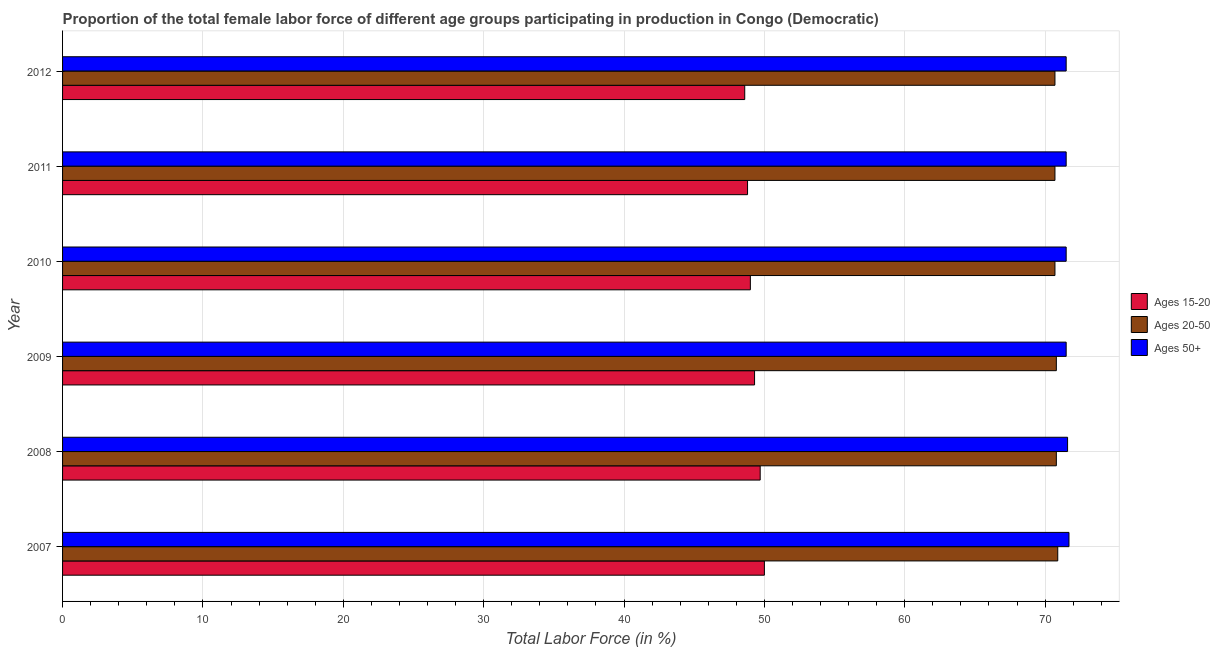Are the number of bars per tick equal to the number of legend labels?
Offer a terse response. Yes. Are the number of bars on each tick of the Y-axis equal?
Ensure brevity in your answer.  Yes. What is the label of the 6th group of bars from the top?
Provide a succinct answer. 2007. In how many cases, is the number of bars for a given year not equal to the number of legend labels?
Your response must be concise. 0. What is the percentage of female labor force above age 50 in 2007?
Offer a very short reply. 71.7. Across all years, what is the maximum percentage of female labor force within the age group 15-20?
Give a very brief answer. 50. Across all years, what is the minimum percentage of female labor force above age 50?
Your answer should be very brief. 71.5. What is the total percentage of female labor force above age 50 in the graph?
Provide a short and direct response. 429.3. What is the difference between the percentage of female labor force within the age group 20-50 in 2010 and that in 2011?
Give a very brief answer. 0. What is the difference between the percentage of female labor force within the age group 20-50 in 2010 and the percentage of female labor force above age 50 in 2009?
Your answer should be very brief. -0.8. What is the average percentage of female labor force above age 50 per year?
Keep it short and to the point. 71.55. In the year 2011, what is the difference between the percentage of female labor force within the age group 15-20 and percentage of female labor force within the age group 20-50?
Keep it short and to the point. -21.9. In how many years, is the percentage of female labor force above age 50 greater than 56 %?
Your answer should be very brief. 6. What is the ratio of the percentage of female labor force within the age group 15-20 in 2010 to that in 2012?
Ensure brevity in your answer.  1.01. Is the percentage of female labor force above age 50 in 2007 less than that in 2012?
Your response must be concise. No. Is the difference between the percentage of female labor force within the age group 15-20 in 2010 and 2011 greater than the difference between the percentage of female labor force within the age group 20-50 in 2010 and 2011?
Give a very brief answer. Yes. What is the difference between the highest and the second highest percentage of female labor force within the age group 20-50?
Offer a terse response. 0.1. Is the sum of the percentage of female labor force above age 50 in 2008 and 2010 greater than the maximum percentage of female labor force within the age group 20-50 across all years?
Keep it short and to the point. Yes. What does the 2nd bar from the top in 2009 represents?
Keep it short and to the point. Ages 20-50. What does the 3rd bar from the bottom in 2007 represents?
Offer a very short reply. Ages 50+. Is it the case that in every year, the sum of the percentage of female labor force within the age group 15-20 and percentage of female labor force within the age group 20-50 is greater than the percentage of female labor force above age 50?
Your response must be concise. Yes. How many bars are there?
Provide a short and direct response. 18. Are all the bars in the graph horizontal?
Offer a very short reply. Yes. Does the graph contain any zero values?
Keep it short and to the point. No. Does the graph contain grids?
Make the answer very short. Yes. Where does the legend appear in the graph?
Offer a terse response. Center right. How many legend labels are there?
Give a very brief answer. 3. How are the legend labels stacked?
Make the answer very short. Vertical. What is the title of the graph?
Make the answer very short. Proportion of the total female labor force of different age groups participating in production in Congo (Democratic). What is the Total Labor Force (in %) in Ages 15-20 in 2007?
Your response must be concise. 50. What is the Total Labor Force (in %) in Ages 20-50 in 2007?
Offer a very short reply. 70.9. What is the Total Labor Force (in %) in Ages 50+ in 2007?
Keep it short and to the point. 71.7. What is the Total Labor Force (in %) of Ages 15-20 in 2008?
Your answer should be compact. 49.7. What is the Total Labor Force (in %) in Ages 20-50 in 2008?
Keep it short and to the point. 70.8. What is the Total Labor Force (in %) in Ages 50+ in 2008?
Your answer should be very brief. 71.6. What is the Total Labor Force (in %) of Ages 15-20 in 2009?
Provide a short and direct response. 49.3. What is the Total Labor Force (in %) of Ages 20-50 in 2009?
Provide a succinct answer. 70.8. What is the Total Labor Force (in %) in Ages 50+ in 2009?
Your response must be concise. 71.5. What is the Total Labor Force (in %) in Ages 15-20 in 2010?
Offer a terse response. 49. What is the Total Labor Force (in %) in Ages 20-50 in 2010?
Offer a very short reply. 70.7. What is the Total Labor Force (in %) of Ages 50+ in 2010?
Provide a succinct answer. 71.5. What is the Total Labor Force (in %) of Ages 15-20 in 2011?
Your response must be concise. 48.8. What is the Total Labor Force (in %) of Ages 20-50 in 2011?
Offer a terse response. 70.7. What is the Total Labor Force (in %) in Ages 50+ in 2011?
Ensure brevity in your answer.  71.5. What is the Total Labor Force (in %) in Ages 15-20 in 2012?
Ensure brevity in your answer.  48.6. What is the Total Labor Force (in %) of Ages 20-50 in 2012?
Make the answer very short. 70.7. What is the Total Labor Force (in %) of Ages 50+ in 2012?
Offer a very short reply. 71.5. Across all years, what is the maximum Total Labor Force (in %) of Ages 15-20?
Keep it short and to the point. 50. Across all years, what is the maximum Total Labor Force (in %) in Ages 20-50?
Offer a terse response. 70.9. Across all years, what is the maximum Total Labor Force (in %) in Ages 50+?
Make the answer very short. 71.7. Across all years, what is the minimum Total Labor Force (in %) in Ages 15-20?
Offer a very short reply. 48.6. Across all years, what is the minimum Total Labor Force (in %) in Ages 20-50?
Your response must be concise. 70.7. Across all years, what is the minimum Total Labor Force (in %) of Ages 50+?
Your answer should be compact. 71.5. What is the total Total Labor Force (in %) of Ages 15-20 in the graph?
Make the answer very short. 295.4. What is the total Total Labor Force (in %) in Ages 20-50 in the graph?
Provide a short and direct response. 424.6. What is the total Total Labor Force (in %) of Ages 50+ in the graph?
Your response must be concise. 429.3. What is the difference between the Total Labor Force (in %) in Ages 15-20 in 2007 and that in 2008?
Provide a succinct answer. 0.3. What is the difference between the Total Labor Force (in %) of Ages 50+ in 2007 and that in 2009?
Make the answer very short. 0.2. What is the difference between the Total Labor Force (in %) in Ages 15-20 in 2007 and that in 2010?
Provide a succinct answer. 1. What is the difference between the Total Labor Force (in %) of Ages 20-50 in 2007 and that in 2010?
Keep it short and to the point. 0.2. What is the difference between the Total Labor Force (in %) in Ages 50+ in 2007 and that in 2010?
Your answer should be very brief. 0.2. What is the difference between the Total Labor Force (in %) of Ages 15-20 in 2007 and that in 2011?
Your answer should be compact. 1.2. What is the difference between the Total Labor Force (in %) in Ages 20-50 in 2007 and that in 2011?
Make the answer very short. 0.2. What is the difference between the Total Labor Force (in %) in Ages 50+ in 2007 and that in 2011?
Keep it short and to the point. 0.2. What is the difference between the Total Labor Force (in %) in Ages 15-20 in 2007 and that in 2012?
Your answer should be very brief. 1.4. What is the difference between the Total Labor Force (in %) in Ages 20-50 in 2007 and that in 2012?
Provide a succinct answer. 0.2. What is the difference between the Total Labor Force (in %) of Ages 50+ in 2007 and that in 2012?
Give a very brief answer. 0.2. What is the difference between the Total Labor Force (in %) in Ages 20-50 in 2008 and that in 2009?
Your answer should be compact. 0. What is the difference between the Total Labor Force (in %) in Ages 50+ in 2008 and that in 2009?
Provide a short and direct response. 0.1. What is the difference between the Total Labor Force (in %) in Ages 15-20 in 2008 and that in 2010?
Offer a very short reply. 0.7. What is the difference between the Total Labor Force (in %) in Ages 50+ in 2008 and that in 2010?
Offer a terse response. 0.1. What is the difference between the Total Labor Force (in %) of Ages 15-20 in 2008 and that in 2011?
Make the answer very short. 0.9. What is the difference between the Total Labor Force (in %) in Ages 20-50 in 2008 and that in 2011?
Your answer should be compact. 0.1. What is the difference between the Total Labor Force (in %) in Ages 50+ in 2008 and that in 2011?
Keep it short and to the point. 0.1. What is the difference between the Total Labor Force (in %) of Ages 15-20 in 2008 and that in 2012?
Offer a very short reply. 1.1. What is the difference between the Total Labor Force (in %) in Ages 15-20 in 2009 and that in 2010?
Offer a terse response. 0.3. What is the difference between the Total Labor Force (in %) in Ages 20-50 in 2009 and that in 2011?
Your response must be concise. 0.1. What is the difference between the Total Labor Force (in %) in Ages 20-50 in 2009 and that in 2012?
Your answer should be very brief. 0.1. What is the difference between the Total Labor Force (in %) in Ages 50+ in 2009 and that in 2012?
Offer a very short reply. 0. What is the difference between the Total Labor Force (in %) in Ages 15-20 in 2010 and that in 2012?
Make the answer very short. 0.4. What is the difference between the Total Labor Force (in %) in Ages 15-20 in 2011 and that in 2012?
Make the answer very short. 0.2. What is the difference between the Total Labor Force (in %) in Ages 20-50 in 2011 and that in 2012?
Provide a succinct answer. 0. What is the difference between the Total Labor Force (in %) in Ages 15-20 in 2007 and the Total Labor Force (in %) in Ages 20-50 in 2008?
Offer a very short reply. -20.8. What is the difference between the Total Labor Force (in %) in Ages 15-20 in 2007 and the Total Labor Force (in %) in Ages 50+ in 2008?
Provide a short and direct response. -21.6. What is the difference between the Total Labor Force (in %) of Ages 15-20 in 2007 and the Total Labor Force (in %) of Ages 20-50 in 2009?
Offer a very short reply. -20.8. What is the difference between the Total Labor Force (in %) in Ages 15-20 in 2007 and the Total Labor Force (in %) in Ages 50+ in 2009?
Your answer should be very brief. -21.5. What is the difference between the Total Labor Force (in %) in Ages 15-20 in 2007 and the Total Labor Force (in %) in Ages 20-50 in 2010?
Offer a terse response. -20.7. What is the difference between the Total Labor Force (in %) in Ages 15-20 in 2007 and the Total Labor Force (in %) in Ages 50+ in 2010?
Make the answer very short. -21.5. What is the difference between the Total Labor Force (in %) of Ages 15-20 in 2007 and the Total Labor Force (in %) of Ages 20-50 in 2011?
Ensure brevity in your answer.  -20.7. What is the difference between the Total Labor Force (in %) of Ages 15-20 in 2007 and the Total Labor Force (in %) of Ages 50+ in 2011?
Provide a succinct answer. -21.5. What is the difference between the Total Labor Force (in %) in Ages 15-20 in 2007 and the Total Labor Force (in %) in Ages 20-50 in 2012?
Offer a very short reply. -20.7. What is the difference between the Total Labor Force (in %) of Ages 15-20 in 2007 and the Total Labor Force (in %) of Ages 50+ in 2012?
Your response must be concise. -21.5. What is the difference between the Total Labor Force (in %) of Ages 20-50 in 2007 and the Total Labor Force (in %) of Ages 50+ in 2012?
Provide a succinct answer. -0.6. What is the difference between the Total Labor Force (in %) of Ages 15-20 in 2008 and the Total Labor Force (in %) of Ages 20-50 in 2009?
Offer a terse response. -21.1. What is the difference between the Total Labor Force (in %) of Ages 15-20 in 2008 and the Total Labor Force (in %) of Ages 50+ in 2009?
Provide a succinct answer. -21.8. What is the difference between the Total Labor Force (in %) in Ages 20-50 in 2008 and the Total Labor Force (in %) in Ages 50+ in 2009?
Give a very brief answer. -0.7. What is the difference between the Total Labor Force (in %) of Ages 15-20 in 2008 and the Total Labor Force (in %) of Ages 20-50 in 2010?
Offer a terse response. -21. What is the difference between the Total Labor Force (in %) of Ages 15-20 in 2008 and the Total Labor Force (in %) of Ages 50+ in 2010?
Provide a succinct answer. -21.8. What is the difference between the Total Labor Force (in %) of Ages 20-50 in 2008 and the Total Labor Force (in %) of Ages 50+ in 2010?
Your response must be concise. -0.7. What is the difference between the Total Labor Force (in %) in Ages 15-20 in 2008 and the Total Labor Force (in %) in Ages 50+ in 2011?
Make the answer very short. -21.8. What is the difference between the Total Labor Force (in %) in Ages 15-20 in 2008 and the Total Labor Force (in %) in Ages 20-50 in 2012?
Your answer should be very brief. -21. What is the difference between the Total Labor Force (in %) in Ages 15-20 in 2008 and the Total Labor Force (in %) in Ages 50+ in 2012?
Offer a very short reply. -21.8. What is the difference between the Total Labor Force (in %) of Ages 15-20 in 2009 and the Total Labor Force (in %) of Ages 20-50 in 2010?
Your answer should be very brief. -21.4. What is the difference between the Total Labor Force (in %) of Ages 15-20 in 2009 and the Total Labor Force (in %) of Ages 50+ in 2010?
Offer a terse response. -22.2. What is the difference between the Total Labor Force (in %) of Ages 20-50 in 2009 and the Total Labor Force (in %) of Ages 50+ in 2010?
Ensure brevity in your answer.  -0.7. What is the difference between the Total Labor Force (in %) of Ages 15-20 in 2009 and the Total Labor Force (in %) of Ages 20-50 in 2011?
Keep it short and to the point. -21.4. What is the difference between the Total Labor Force (in %) in Ages 15-20 in 2009 and the Total Labor Force (in %) in Ages 50+ in 2011?
Your answer should be very brief. -22.2. What is the difference between the Total Labor Force (in %) of Ages 20-50 in 2009 and the Total Labor Force (in %) of Ages 50+ in 2011?
Make the answer very short. -0.7. What is the difference between the Total Labor Force (in %) in Ages 15-20 in 2009 and the Total Labor Force (in %) in Ages 20-50 in 2012?
Your answer should be compact. -21.4. What is the difference between the Total Labor Force (in %) of Ages 15-20 in 2009 and the Total Labor Force (in %) of Ages 50+ in 2012?
Keep it short and to the point. -22.2. What is the difference between the Total Labor Force (in %) in Ages 15-20 in 2010 and the Total Labor Force (in %) in Ages 20-50 in 2011?
Offer a very short reply. -21.7. What is the difference between the Total Labor Force (in %) in Ages 15-20 in 2010 and the Total Labor Force (in %) in Ages 50+ in 2011?
Offer a very short reply. -22.5. What is the difference between the Total Labor Force (in %) in Ages 15-20 in 2010 and the Total Labor Force (in %) in Ages 20-50 in 2012?
Offer a terse response. -21.7. What is the difference between the Total Labor Force (in %) in Ages 15-20 in 2010 and the Total Labor Force (in %) in Ages 50+ in 2012?
Ensure brevity in your answer.  -22.5. What is the difference between the Total Labor Force (in %) in Ages 15-20 in 2011 and the Total Labor Force (in %) in Ages 20-50 in 2012?
Ensure brevity in your answer.  -21.9. What is the difference between the Total Labor Force (in %) of Ages 15-20 in 2011 and the Total Labor Force (in %) of Ages 50+ in 2012?
Provide a short and direct response. -22.7. What is the average Total Labor Force (in %) in Ages 15-20 per year?
Your response must be concise. 49.23. What is the average Total Labor Force (in %) of Ages 20-50 per year?
Your answer should be compact. 70.77. What is the average Total Labor Force (in %) in Ages 50+ per year?
Offer a terse response. 71.55. In the year 2007, what is the difference between the Total Labor Force (in %) in Ages 15-20 and Total Labor Force (in %) in Ages 20-50?
Give a very brief answer. -20.9. In the year 2007, what is the difference between the Total Labor Force (in %) in Ages 15-20 and Total Labor Force (in %) in Ages 50+?
Give a very brief answer. -21.7. In the year 2007, what is the difference between the Total Labor Force (in %) of Ages 20-50 and Total Labor Force (in %) of Ages 50+?
Provide a succinct answer. -0.8. In the year 2008, what is the difference between the Total Labor Force (in %) in Ages 15-20 and Total Labor Force (in %) in Ages 20-50?
Keep it short and to the point. -21.1. In the year 2008, what is the difference between the Total Labor Force (in %) of Ages 15-20 and Total Labor Force (in %) of Ages 50+?
Give a very brief answer. -21.9. In the year 2009, what is the difference between the Total Labor Force (in %) of Ages 15-20 and Total Labor Force (in %) of Ages 20-50?
Make the answer very short. -21.5. In the year 2009, what is the difference between the Total Labor Force (in %) in Ages 15-20 and Total Labor Force (in %) in Ages 50+?
Offer a very short reply. -22.2. In the year 2009, what is the difference between the Total Labor Force (in %) of Ages 20-50 and Total Labor Force (in %) of Ages 50+?
Ensure brevity in your answer.  -0.7. In the year 2010, what is the difference between the Total Labor Force (in %) in Ages 15-20 and Total Labor Force (in %) in Ages 20-50?
Provide a succinct answer. -21.7. In the year 2010, what is the difference between the Total Labor Force (in %) in Ages 15-20 and Total Labor Force (in %) in Ages 50+?
Provide a succinct answer. -22.5. In the year 2011, what is the difference between the Total Labor Force (in %) in Ages 15-20 and Total Labor Force (in %) in Ages 20-50?
Ensure brevity in your answer.  -21.9. In the year 2011, what is the difference between the Total Labor Force (in %) of Ages 15-20 and Total Labor Force (in %) of Ages 50+?
Your answer should be compact. -22.7. In the year 2012, what is the difference between the Total Labor Force (in %) in Ages 15-20 and Total Labor Force (in %) in Ages 20-50?
Ensure brevity in your answer.  -22.1. In the year 2012, what is the difference between the Total Labor Force (in %) of Ages 15-20 and Total Labor Force (in %) of Ages 50+?
Keep it short and to the point. -22.9. What is the ratio of the Total Labor Force (in %) of Ages 20-50 in 2007 to that in 2008?
Your answer should be very brief. 1. What is the ratio of the Total Labor Force (in %) in Ages 50+ in 2007 to that in 2008?
Keep it short and to the point. 1. What is the ratio of the Total Labor Force (in %) of Ages 15-20 in 2007 to that in 2009?
Provide a short and direct response. 1.01. What is the ratio of the Total Labor Force (in %) in Ages 15-20 in 2007 to that in 2010?
Give a very brief answer. 1.02. What is the ratio of the Total Labor Force (in %) in Ages 50+ in 2007 to that in 2010?
Keep it short and to the point. 1. What is the ratio of the Total Labor Force (in %) in Ages 15-20 in 2007 to that in 2011?
Your answer should be compact. 1.02. What is the ratio of the Total Labor Force (in %) in Ages 50+ in 2007 to that in 2011?
Give a very brief answer. 1. What is the ratio of the Total Labor Force (in %) of Ages 15-20 in 2007 to that in 2012?
Offer a very short reply. 1.03. What is the ratio of the Total Labor Force (in %) of Ages 50+ in 2007 to that in 2012?
Ensure brevity in your answer.  1. What is the ratio of the Total Labor Force (in %) of Ages 15-20 in 2008 to that in 2009?
Your answer should be very brief. 1.01. What is the ratio of the Total Labor Force (in %) of Ages 20-50 in 2008 to that in 2009?
Provide a succinct answer. 1. What is the ratio of the Total Labor Force (in %) of Ages 50+ in 2008 to that in 2009?
Your answer should be very brief. 1. What is the ratio of the Total Labor Force (in %) in Ages 15-20 in 2008 to that in 2010?
Provide a succinct answer. 1.01. What is the ratio of the Total Labor Force (in %) in Ages 15-20 in 2008 to that in 2011?
Offer a very short reply. 1.02. What is the ratio of the Total Labor Force (in %) of Ages 20-50 in 2008 to that in 2011?
Provide a short and direct response. 1. What is the ratio of the Total Labor Force (in %) in Ages 50+ in 2008 to that in 2011?
Give a very brief answer. 1. What is the ratio of the Total Labor Force (in %) of Ages 15-20 in 2008 to that in 2012?
Offer a terse response. 1.02. What is the ratio of the Total Labor Force (in %) in Ages 15-20 in 2009 to that in 2011?
Offer a terse response. 1.01. What is the ratio of the Total Labor Force (in %) of Ages 15-20 in 2009 to that in 2012?
Your answer should be compact. 1.01. What is the ratio of the Total Labor Force (in %) of Ages 20-50 in 2009 to that in 2012?
Offer a very short reply. 1. What is the ratio of the Total Labor Force (in %) in Ages 50+ in 2009 to that in 2012?
Offer a very short reply. 1. What is the ratio of the Total Labor Force (in %) of Ages 15-20 in 2010 to that in 2011?
Your response must be concise. 1. What is the ratio of the Total Labor Force (in %) in Ages 15-20 in 2010 to that in 2012?
Keep it short and to the point. 1.01. What is the ratio of the Total Labor Force (in %) of Ages 20-50 in 2011 to that in 2012?
Provide a succinct answer. 1. What is the difference between the highest and the second highest Total Labor Force (in %) of Ages 15-20?
Give a very brief answer. 0.3. What is the difference between the highest and the second highest Total Labor Force (in %) of Ages 50+?
Ensure brevity in your answer.  0.1. What is the difference between the highest and the lowest Total Labor Force (in %) in Ages 15-20?
Give a very brief answer. 1.4. What is the difference between the highest and the lowest Total Labor Force (in %) in Ages 20-50?
Provide a succinct answer. 0.2. What is the difference between the highest and the lowest Total Labor Force (in %) in Ages 50+?
Keep it short and to the point. 0.2. 